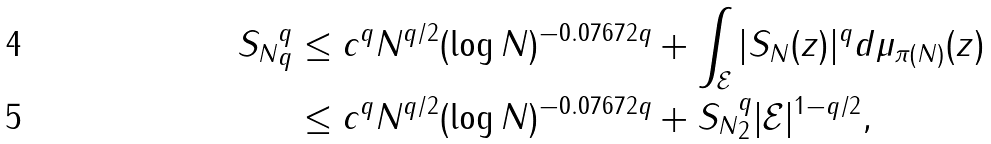<formula> <loc_0><loc_0><loc_500><loc_500>\| S _ { N } \| _ { q } ^ { q } & \leq c ^ { q } N ^ { q / 2 } ( \log N ) ^ { - 0 . 0 7 6 7 2 q } + \int _ { \mathcal { E } } | S _ { N } ( z ) | ^ { q } d \mu _ { \pi ( N ) } ( z ) \\ & \leq c ^ { q } N ^ { q / 2 } ( \log N ) ^ { - 0 . 0 7 6 7 2 q } + \| S _ { N } \| _ { 2 } ^ { q } | { \mathcal { E } } | ^ { 1 - q / 2 } ,</formula> 